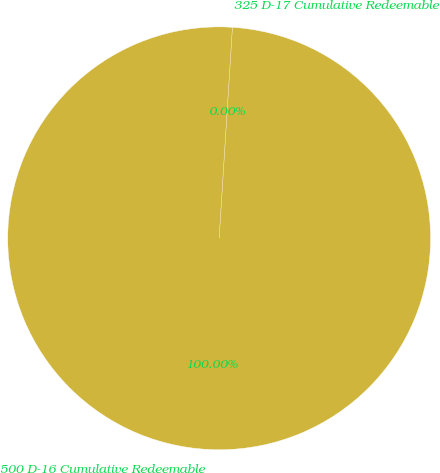Convert chart to OTSL. <chart><loc_0><loc_0><loc_500><loc_500><pie_chart><fcel>500 D-16 Cumulative Redeemable<fcel>325 D-17 Cumulative Redeemable<nl><fcel>100.0%<fcel>0.0%<nl></chart> 